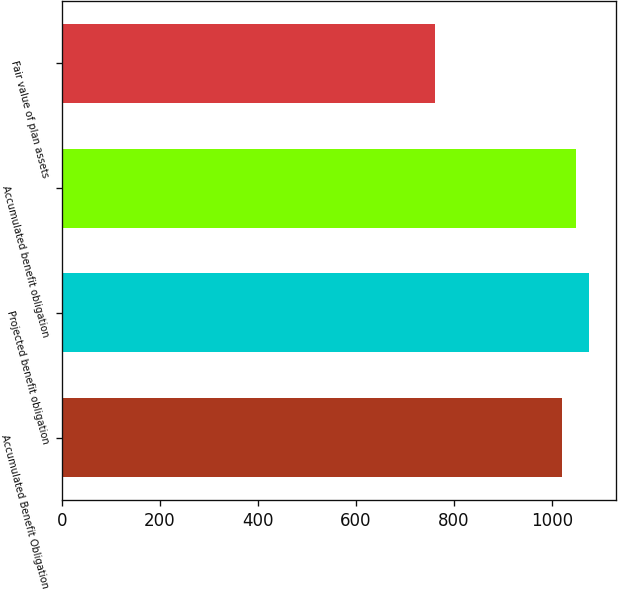Convert chart. <chart><loc_0><loc_0><loc_500><loc_500><bar_chart><fcel>Accumulated Benefit Obligation<fcel>Projected benefit obligation<fcel>Accumulated benefit obligation<fcel>Fair value of plan assets<nl><fcel>1020<fcel>1076.4<fcel>1048.2<fcel>762<nl></chart> 